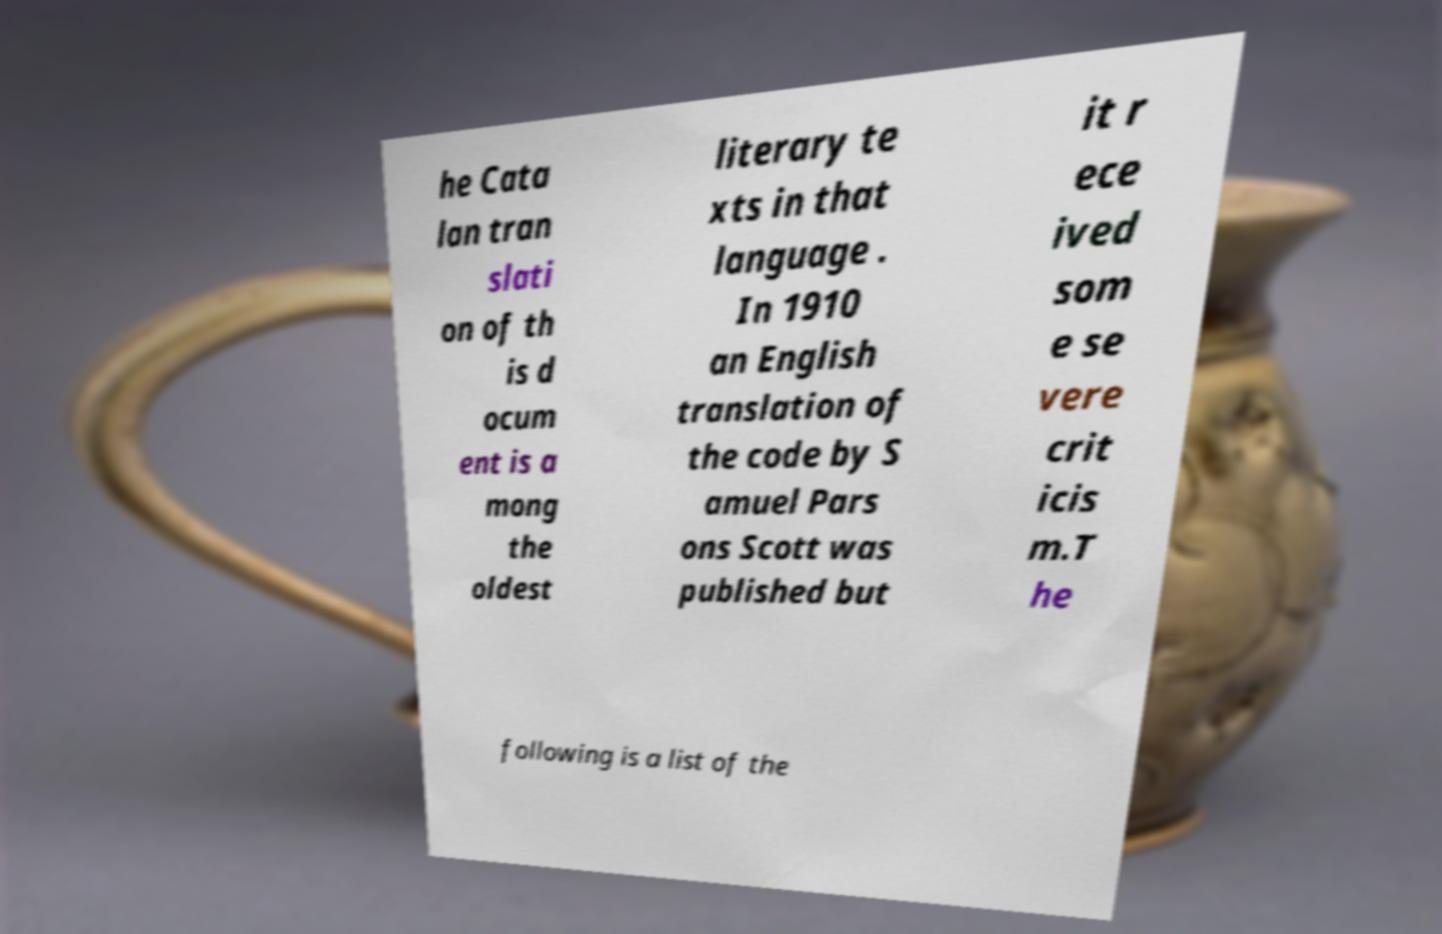Please read and relay the text visible in this image. What does it say? he Cata lan tran slati on of th is d ocum ent is a mong the oldest literary te xts in that language . In 1910 an English translation of the code by S amuel Pars ons Scott was published but it r ece ived som e se vere crit icis m.T he following is a list of the 